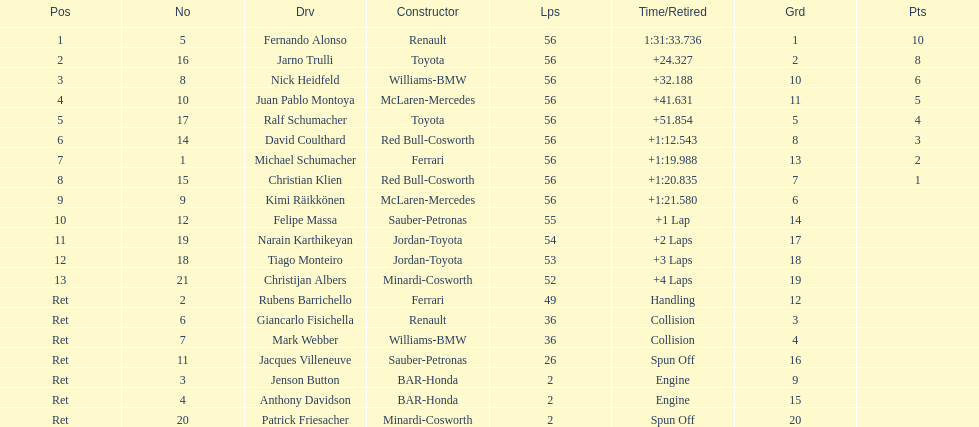Who finished before nick heidfeld? Jarno Trulli. 